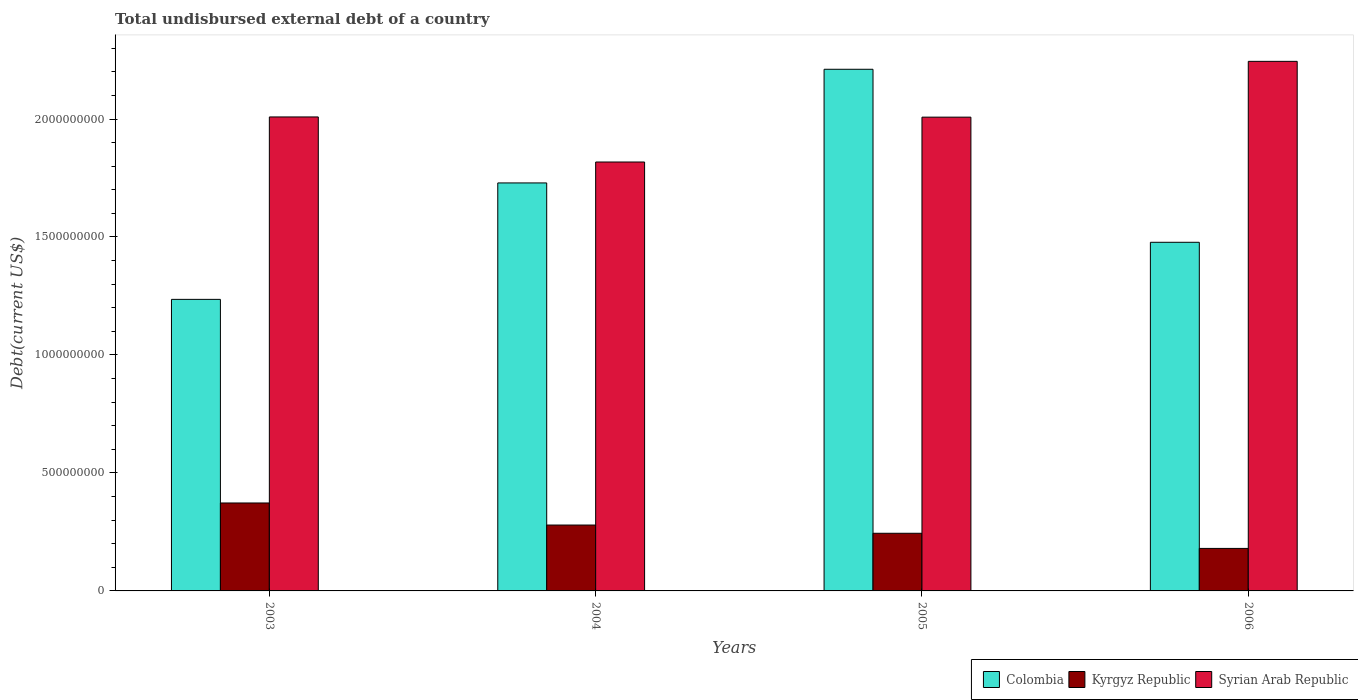How many groups of bars are there?
Provide a succinct answer. 4. Are the number of bars on each tick of the X-axis equal?
Make the answer very short. Yes. How many bars are there on the 4th tick from the right?
Your answer should be compact. 3. What is the label of the 1st group of bars from the left?
Your answer should be compact. 2003. What is the total undisbursed external debt in Colombia in 2003?
Offer a very short reply. 1.24e+09. Across all years, what is the maximum total undisbursed external debt in Colombia?
Provide a succinct answer. 2.21e+09. Across all years, what is the minimum total undisbursed external debt in Syrian Arab Republic?
Your response must be concise. 1.82e+09. In which year was the total undisbursed external debt in Syrian Arab Republic minimum?
Give a very brief answer. 2004. What is the total total undisbursed external debt in Syrian Arab Republic in the graph?
Ensure brevity in your answer.  8.08e+09. What is the difference between the total undisbursed external debt in Kyrgyz Republic in 2003 and that in 2005?
Offer a very short reply. 1.28e+08. What is the difference between the total undisbursed external debt in Kyrgyz Republic in 2003 and the total undisbursed external debt in Colombia in 2005?
Your answer should be compact. -1.84e+09. What is the average total undisbursed external debt in Syrian Arab Republic per year?
Give a very brief answer. 2.02e+09. In the year 2006, what is the difference between the total undisbursed external debt in Kyrgyz Republic and total undisbursed external debt in Syrian Arab Republic?
Provide a short and direct response. -2.06e+09. What is the ratio of the total undisbursed external debt in Kyrgyz Republic in 2004 to that in 2005?
Make the answer very short. 1.14. What is the difference between the highest and the second highest total undisbursed external debt in Kyrgyz Republic?
Make the answer very short. 9.35e+07. What is the difference between the highest and the lowest total undisbursed external debt in Kyrgyz Republic?
Offer a very short reply. 1.93e+08. In how many years, is the total undisbursed external debt in Kyrgyz Republic greater than the average total undisbursed external debt in Kyrgyz Republic taken over all years?
Your answer should be compact. 2. Is the sum of the total undisbursed external debt in Syrian Arab Republic in 2004 and 2006 greater than the maximum total undisbursed external debt in Kyrgyz Republic across all years?
Keep it short and to the point. Yes. What does the 2nd bar from the left in 2004 represents?
Provide a short and direct response. Kyrgyz Republic. What does the 2nd bar from the right in 2003 represents?
Keep it short and to the point. Kyrgyz Republic. How many bars are there?
Provide a short and direct response. 12. Are the values on the major ticks of Y-axis written in scientific E-notation?
Ensure brevity in your answer.  No. How are the legend labels stacked?
Keep it short and to the point. Horizontal. What is the title of the graph?
Your answer should be compact. Total undisbursed external debt of a country. What is the label or title of the X-axis?
Your answer should be very brief. Years. What is the label or title of the Y-axis?
Offer a very short reply. Debt(current US$). What is the Debt(current US$) in Colombia in 2003?
Keep it short and to the point. 1.24e+09. What is the Debt(current US$) of Kyrgyz Republic in 2003?
Your response must be concise. 3.73e+08. What is the Debt(current US$) in Syrian Arab Republic in 2003?
Make the answer very short. 2.01e+09. What is the Debt(current US$) in Colombia in 2004?
Your answer should be compact. 1.73e+09. What is the Debt(current US$) of Kyrgyz Republic in 2004?
Provide a succinct answer. 2.79e+08. What is the Debt(current US$) in Syrian Arab Republic in 2004?
Your answer should be very brief. 1.82e+09. What is the Debt(current US$) in Colombia in 2005?
Ensure brevity in your answer.  2.21e+09. What is the Debt(current US$) of Kyrgyz Republic in 2005?
Your response must be concise. 2.44e+08. What is the Debt(current US$) in Syrian Arab Republic in 2005?
Provide a short and direct response. 2.01e+09. What is the Debt(current US$) of Colombia in 2006?
Your answer should be very brief. 1.48e+09. What is the Debt(current US$) in Kyrgyz Republic in 2006?
Ensure brevity in your answer.  1.80e+08. What is the Debt(current US$) of Syrian Arab Republic in 2006?
Keep it short and to the point. 2.24e+09. Across all years, what is the maximum Debt(current US$) of Colombia?
Offer a very short reply. 2.21e+09. Across all years, what is the maximum Debt(current US$) in Kyrgyz Republic?
Give a very brief answer. 3.73e+08. Across all years, what is the maximum Debt(current US$) in Syrian Arab Republic?
Your response must be concise. 2.24e+09. Across all years, what is the minimum Debt(current US$) in Colombia?
Make the answer very short. 1.24e+09. Across all years, what is the minimum Debt(current US$) in Kyrgyz Republic?
Provide a short and direct response. 1.80e+08. Across all years, what is the minimum Debt(current US$) of Syrian Arab Republic?
Provide a short and direct response. 1.82e+09. What is the total Debt(current US$) in Colombia in the graph?
Keep it short and to the point. 6.65e+09. What is the total Debt(current US$) in Kyrgyz Republic in the graph?
Keep it short and to the point. 1.08e+09. What is the total Debt(current US$) in Syrian Arab Republic in the graph?
Your answer should be very brief. 8.08e+09. What is the difference between the Debt(current US$) of Colombia in 2003 and that in 2004?
Keep it short and to the point. -4.93e+08. What is the difference between the Debt(current US$) of Kyrgyz Republic in 2003 and that in 2004?
Your answer should be compact. 9.35e+07. What is the difference between the Debt(current US$) of Syrian Arab Republic in 2003 and that in 2004?
Keep it short and to the point. 1.91e+08. What is the difference between the Debt(current US$) in Colombia in 2003 and that in 2005?
Provide a succinct answer. -9.75e+08. What is the difference between the Debt(current US$) in Kyrgyz Republic in 2003 and that in 2005?
Your answer should be very brief. 1.28e+08. What is the difference between the Debt(current US$) of Syrian Arab Republic in 2003 and that in 2005?
Keep it short and to the point. 8.62e+05. What is the difference between the Debt(current US$) in Colombia in 2003 and that in 2006?
Your answer should be compact. -2.42e+08. What is the difference between the Debt(current US$) in Kyrgyz Republic in 2003 and that in 2006?
Provide a short and direct response. 1.93e+08. What is the difference between the Debt(current US$) of Syrian Arab Republic in 2003 and that in 2006?
Keep it short and to the point. -2.36e+08. What is the difference between the Debt(current US$) in Colombia in 2004 and that in 2005?
Offer a very short reply. -4.82e+08. What is the difference between the Debt(current US$) in Kyrgyz Republic in 2004 and that in 2005?
Your response must be concise. 3.48e+07. What is the difference between the Debt(current US$) in Syrian Arab Republic in 2004 and that in 2005?
Ensure brevity in your answer.  -1.90e+08. What is the difference between the Debt(current US$) in Colombia in 2004 and that in 2006?
Offer a very short reply. 2.52e+08. What is the difference between the Debt(current US$) in Kyrgyz Republic in 2004 and that in 2006?
Your response must be concise. 9.90e+07. What is the difference between the Debt(current US$) of Syrian Arab Republic in 2004 and that in 2006?
Ensure brevity in your answer.  -4.27e+08. What is the difference between the Debt(current US$) in Colombia in 2005 and that in 2006?
Give a very brief answer. 7.33e+08. What is the difference between the Debt(current US$) in Kyrgyz Republic in 2005 and that in 2006?
Keep it short and to the point. 6.42e+07. What is the difference between the Debt(current US$) in Syrian Arab Republic in 2005 and that in 2006?
Your response must be concise. -2.36e+08. What is the difference between the Debt(current US$) in Colombia in 2003 and the Debt(current US$) in Kyrgyz Republic in 2004?
Make the answer very short. 9.56e+08. What is the difference between the Debt(current US$) of Colombia in 2003 and the Debt(current US$) of Syrian Arab Republic in 2004?
Provide a short and direct response. -5.82e+08. What is the difference between the Debt(current US$) in Kyrgyz Republic in 2003 and the Debt(current US$) in Syrian Arab Republic in 2004?
Make the answer very short. -1.45e+09. What is the difference between the Debt(current US$) of Colombia in 2003 and the Debt(current US$) of Kyrgyz Republic in 2005?
Your answer should be compact. 9.91e+08. What is the difference between the Debt(current US$) in Colombia in 2003 and the Debt(current US$) in Syrian Arab Republic in 2005?
Provide a succinct answer. -7.72e+08. What is the difference between the Debt(current US$) in Kyrgyz Republic in 2003 and the Debt(current US$) in Syrian Arab Republic in 2005?
Provide a succinct answer. -1.64e+09. What is the difference between the Debt(current US$) in Colombia in 2003 and the Debt(current US$) in Kyrgyz Republic in 2006?
Provide a short and direct response. 1.06e+09. What is the difference between the Debt(current US$) in Colombia in 2003 and the Debt(current US$) in Syrian Arab Republic in 2006?
Provide a succinct answer. -1.01e+09. What is the difference between the Debt(current US$) in Kyrgyz Republic in 2003 and the Debt(current US$) in Syrian Arab Republic in 2006?
Offer a terse response. -1.87e+09. What is the difference between the Debt(current US$) in Colombia in 2004 and the Debt(current US$) in Kyrgyz Republic in 2005?
Provide a short and direct response. 1.48e+09. What is the difference between the Debt(current US$) in Colombia in 2004 and the Debt(current US$) in Syrian Arab Republic in 2005?
Give a very brief answer. -2.79e+08. What is the difference between the Debt(current US$) of Kyrgyz Republic in 2004 and the Debt(current US$) of Syrian Arab Republic in 2005?
Provide a succinct answer. -1.73e+09. What is the difference between the Debt(current US$) in Colombia in 2004 and the Debt(current US$) in Kyrgyz Republic in 2006?
Your answer should be very brief. 1.55e+09. What is the difference between the Debt(current US$) of Colombia in 2004 and the Debt(current US$) of Syrian Arab Republic in 2006?
Provide a short and direct response. -5.15e+08. What is the difference between the Debt(current US$) of Kyrgyz Republic in 2004 and the Debt(current US$) of Syrian Arab Republic in 2006?
Offer a terse response. -1.97e+09. What is the difference between the Debt(current US$) in Colombia in 2005 and the Debt(current US$) in Kyrgyz Republic in 2006?
Ensure brevity in your answer.  2.03e+09. What is the difference between the Debt(current US$) in Colombia in 2005 and the Debt(current US$) in Syrian Arab Republic in 2006?
Make the answer very short. -3.36e+07. What is the difference between the Debt(current US$) of Kyrgyz Republic in 2005 and the Debt(current US$) of Syrian Arab Republic in 2006?
Your response must be concise. -2.00e+09. What is the average Debt(current US$) of Colombia per year?
Your response must be concise. 1.66e+09. What is the average Debt(current US$) in Kyrgyz Republic per year?
Give a very brief answer. 2.69e+08. What is the average Debt(current US$) of Syrian Arab Republic per year?
Your answer should be compact. 2.02e+09. In the year 2003, what is the difference between the Debt(current US$) of Colombia and Debt(current US$) of Kyrgyz Republic?
Ensure brevity in your answer.  8.63e+08. In the year 2003, what is the difference between the Debt(current US$) in Colombia and Debt(current US$) in Syrian Arab Republic?
Offer a terse response. -7.73e+08. In the year 2003, what is the difference between the Debt(current US$) in Kyrgyz Republic and Debt(current US$) in Syrian Arab Republic?
Provide a succinct answer. -1.64e+09. In the year 2004, what is the difference between the Debt(current US$) in Colombia and Debt(current US$) in Kyrgyz Republic?
Your response must be concise. 1.45e+09. In the year 2004, what is the difference between the Debt(current US$) in Colombia and Debt(current US$) in Syrian Arab Republic?
Keep it short and to the point. -8.87e+07. In the year 2004, what is the difference between the Debt(current US$) in Kyrgyz Republic and Debt(current US$) in Syrian Arab Republic?
Your answer should be compact. -1.54e+09. In the year 2005, what is the difference between the Debt(current US$) in Colombia and Debt(current US$) in Kyrgyz Republic?
Provide a short and direct response. 1.97e+09. In the year 2005, what is the difference between the Debt(current US$) of Colombia and Debt(current US$) of Syrian Arab Republic?
Keep it short and to the point. 2.03e+08. In the year 2005, what is the difference between the Debt(current US$) in Kyrgyz Republic and Debt(current US$) in Syrian Arab Republic?
Ensure brevity in your answer.  -1.76e+09. In the year 2006, what is the difference between the Debt(current US$) in Colombia and Debt(current US$) in Kyrgyz Republic?
Provide a succinct answer. 1.30e+09. In the year 2006, what is the difference between the Debt(current US$) in Colombia and Debt(current US$) in Syrian Arab Republic?
Your answer should be very brief. -7.67e+08. In the year 2006, what is the difference between the Debt(current US$) in Kyrgyz Republic and Debt(current US$) in Syrian Arab Republic?
Offer a very short reply. -2.06e+09. What is the ratio of the Debt(current US$) in Colombia in 2003 to that in 2004?
Provide a succinct answer. 0.71. What is the ratio of the Debt(current US$) in Kyrgyz Republic in 2003 to that in 2004?
Give a very brief answer. 1.33. What is the ratio of the Debt(current US$) of Syrian Arab Republic in 2003 to that in 2004?
Provide a short and direct response. 1.11. What is the ratio of the Debt(current US$) in Colombia in 2003 to that in 2005?
Keep it short and to the point. 0.56. What is the ratio of the Debt(current US$) of Kyrgyz Republic in 2003 to that in 2005?
Give a very brief answer. 1.53. What is the ratio of the Debt(current US$) in Syrian Arab Republic in 2003 to that in 2005?
Your answer should be very brief. 1. What is the ratio of the Debt(current US$) in Colombia in 2003 to that in 2006?
Offer a very short reply. 0.84. What is the ratio of the Debt(current US$) in Kyrgyz Republic in 2003 to that in 2006?
Your response must be concise. 2.07. What is the ratio of the Debt(current US$) in Syrian Arab Republic in 2003 to that in 2006?
Make the answer very short. 0.9. What is the ratio of the Debt(current US$) of Colombia in 2004 to that in 2005?
Make the answer very short. 0.78. What is the ratio of the Debt(current US$) of Kyrgyz Republic in 2004 to that in 2005?
Keep it short and to the point. 1.14. What is the ratio of the Debt(current US$) in Syrian Arab Republic in 2004 to that in 2005?
Your response must be concise. 0.91. What is the ratio of the Debt(current US$) in Colombia in 2004 to that in 2006?
Your answer should be compact. 1.17. What is the ratio of the Debt(current US$) of Kyrgyz Republic in 2004 to that in 2006?
Your answer should be compact. 1.55. What is the ratio of the Debt(current US$) of Syrian Arab Republic in 2004 to that in 2006?
Your response must be concise. 0.81. What is the ratio of the Debt(current US$) of Colombia in 2005 to that in 2006?
Offer a terse response. 1.5. What is the ratio of the Debt(current US$) in Kyrgyz Republic in 2005 to that in 2006?
Your answer should be very brief. 1.36. What is the ratio of the Debt(current US$) of Syrian Arab Republic in 2005 to that in 2006?
Provide a succinct answer. 0.89. What is the difference between the highest and the second highest Debt(current US$) of Colombia?
Give a very brief answer. 4.82e+08. What is the difference between the highest and the second highest Debt(current US$) in Kyrgyz Republic?
Provide a short and direct response. 9.35e+07. What is the difference between the highest and the second highest Debt(current US$) in Syrian Arab Republic?
Offer a terse response. 2.36e+08. What is the difference between the highest and the lowest Debt(current US$) in Colombia?
Offer a very short reply. 9.75e+08. What is the difference between the highest and the lowest Debt(current US$) of Kyrgyz Republic?
Offer a very short reply. 1.93e+08. What is the difference between the highest and the lowest Debt(current US$) in Syrian Arab Republic?
Make the answer very short. 4.27e+08. 